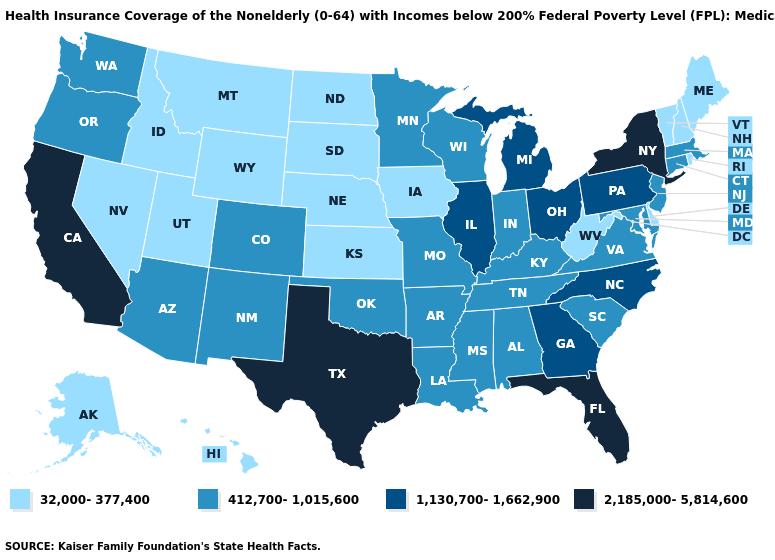What is the value of Alaska?
Quick response, please. 32,000-377,400. Does Oregon have the lowest value in the West?
Keep it brief. No. Does the first symbol in the legend represent the smallest category?
Concise answer only. Yes. Which states hav the highest value in the West?
Quick response, please. California. Among the states that border New Mexico , does Colorado have the highest value?
Answer briefly. No. Which states have the lowest value in the USA?
Quick response, please. Alaska, Delaware, Hawaii, Idaho, Iowa, Kansas, Maine, Montana, Nebraska, Nevada, New Hampshire, North Dakota, Rhode Island, South Dakota, Utah, Vermont, West Virginia, Wyoming. What is the lowest value in the South?
Concise answer only. 32,000-377,400. Does Oregon have the lowest value in the USA?
Concise answer only. No. Does Texas have a higher value than Florida?
Keep it brief. No. What is the value of Rhode Island?
Be succinct. 32,000-377,400. What is the value of Arizona?
Answer briefly. 412,700-1,015,600. What is the value of Utah?
Quick response, please. 32,000-377,400. Among the states that border Washington , which have the lowest value?
Quick response, please. Idaho. Among the states that border Texas , which have the lowest value?
Keep it brief. Arkansas, Louisiana, New Mexico, Oklahoma. Which states have the lowest value in the Northeast?
Answer briefly. Maine, New Hampshire, Rhode Island, Vermont. 